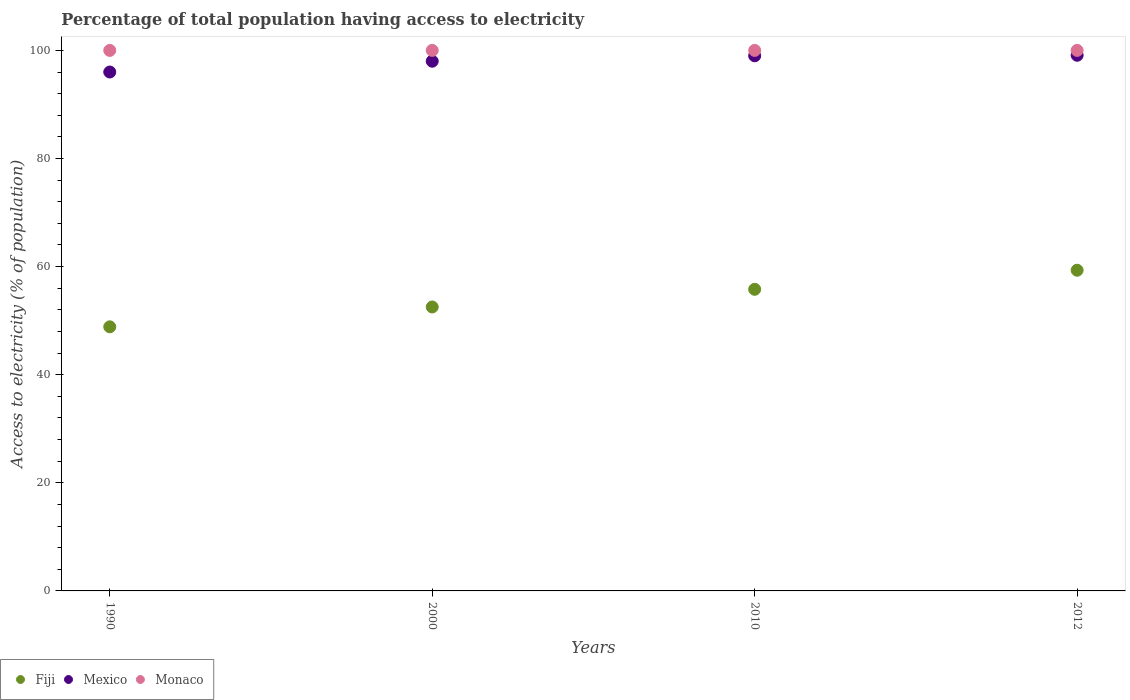What is the percentage of population that have access to electricity in Monaco in 2012?
Provide a short and direct response. 100. Across all years, what is the maximum percentage of population that have access to electricity in Mexico?
Provide a succinct answer. 99.1. Across all years, what is the minimum percentage of population that have access to electricity in Fiji?
Give a very brief answer. 48.86. In which year was the percentage of population that have access to electricity in Fiji minimum?
Offer a very short reply. 1990. What is the total percentage of population that have access to electricity in Fiji in the graph?
Your response must be concise. 216.52. What is the difference between the percentage of population that have access to electricity in Fiji in 1990 and that in 2010?
Your answer should be compact. -6.94. What is the difference between the percentage of population that have access to electricity in Monaco in 1990 and the percentage of population that have access to electricity in Fiji in 2000?
Your answer should be very brief. 47.47. What is the average percentage of population that have access to electricity in Mexico per year?
Your answer should be very brief. 98.03. In the year 2000, what is the difference between the percentage of population that have access to electricity in Monaco and percentage of population that have access to electricity in Fiji?
Provide a short and direct response. 47.47. Is the percentage of population that have access to electricity in Mexico in 2000 less than that in 2012?
Your answer should be very brief. Yes. Is the difference between the percentage of population that have access to electricity in Monaco in 1990 and 2012 greater than the difference between the percentage of population that have access to electricity in Fiji in 1990 and 2012?
Make the answer very short. Yes. What is the difference between the highest and the second highest percentage of population that have access to electricity in Monaco?
Give a very brief answer. 0. What is the difference between the highest and the lowest percentage of population that have access to electricity in Mexico?
Your answer should be compact. 3.1. Is the sum of the percentage of population that have access to electricity in Mexico in 2000 and 2012 greater than the maximum percentage of population that have access to electricity in Fiji across all years?
Ensure brevity in your answer.  Yes. How many years are there in the graph?
Your response must be concise. 4. Does the graph contain grids?
Your answer should be compact. No. How many legend labels are there?
Provide a short and direct response. 3. What is the title of the graph?
Ensure brevity in your answer.  Percentage of total population having access to electricity. What is the label or title of the X-axis?
Provide a short and direct response. Years. What is the label or title of the Y-axis?
Your answer should be very brief. Access to electricity (% of population). What is the Access to electricity (% of population) in Fiji in 1990?
Offer a very short reply. 48.86. What is the Access to electricity (% of population) in Mexico in 1990?
Make the answer very short. 96. What is the Access to electricity (% of population) in Monaco in 1990?
Offer a terse response. 100. What is the Access to electricity (% of population) of Fiji in 2000?
Keep it short and to the point. 52.53. What is the Access to electricity (% of population) of Monaco in 2000?
Provide a short and direct response. 100. What is the Access to electricity (% of population) in Fiji in 2010?
Offer a very short reply. 55.8. What is the Access to electricity (% of population) of Fiji in 2012?
Make the answer very short. 59.33. What is the Access to electricity (% of population) of Mexico in 2012?
Offer a terse response. 99.1. What is the Access to electricity (% of population) of Monaco in 2012?
Ensure brevity in your answer.  100. Across all years, what is the maximum Access to electricity (% of population) of Fiji?
Provide a short and direct response. 59.33. Across all years, what is the maximum Access to electricity (% of population) in Mexico?
Your answer should be very brief. 99.1. Across all years, what is the maximum Access to electricity (% of population) of Monaco?
Give a very brief answer. 100. Across all years, what is the minimum Access to electricity (% of population) of Fiji?
Your response must be concise. 48.86. Across all years, what is the minimum Access to electricity (% of population) of Mexico?
Ensure brevity in your answer.  96. What is the total Access to electricity (% of population) of Fiji in the graph?
Your response must be concise. 216.52. What is the total Access to electricity (% of population) of Mexico in the graph?
Your response must be concise. 392.1. What is the total Access to electricity (% of population) of Monaco in the graph?
Ensure brevity in your answer.  400. What is the difference between the Access to electricity (% of population) in Fiji in 1990 and that in 2000?
Provide a short and direct response. -3.67. What is the difference between the Access to electricity (% of population) of Monaco in 1990 and that in 2000?
Offer a terse response. 0. What is the difference between the Access to electricity (% of population) of Fiji in 1990 and that in 2010?
Make the answer very short. -6.94. What is the difference between the Access to electricity (% of population) of Monaco in 1990 and that in 2010?
Your answer should be compact. 0. What is the difference between the Access to electricity (% of population) of Fiji in 1990 and that in 2012?
Ensure brevity in your answer.  -10.47. What is the difference between the Access to electricity (% of population) of Mexico in 1990 and that in 2012?
Offer a very short reply. -3.1. What is the difference between the Access to electricity (% of population) in Fiji in 2000 and that in 2010?
Keep it short and to the point. -3.27. What is the difference between the Access to electricity (% of population) in Mexico in 2000 and that in 2010?
Your response must be concise. -1. What is the difference between the Access to electricity (% of population) in Fiji in 2000 and that in 2012?
Give a very brief answer. -6.8. What is the difference between the Access to electricity (% of population) of Monaco in 2000 and that in 2012?
Your answer should be compact. 0. What is the difference between the Access to electricity (% of population) of Fiji in 2010 and that in 2012?
Make the answer very short. -3.53. What is the difference between the Access to electricity (% of population) in Monaco in 2010 and that in 2012?
Your answer should be compact. 0. What is the difference between the Access to electricity (% of population) in Fiji in 1990 and the Access to electricity (% of population) in Mexico in 2000?
Keep it short and to the point. -49.14. What is the difference between the Access to electricity (% of population) of Fiji in 1990 and the Access to electricity (% of population) of Monaco in 2000?
Your response must be concise. -51.14. What is the difference between the Access to electricity (% of population) of Mexico in 1990 and the Access to electricity (% of population) of Monaco in 2000?
Make the answer very short. -4. What is the difference between the Access to electricity (% of population) in Fiji in 1990 and the Access to electricity (% of population) in Mexico in 2010?
Your answer should be compact. -50.14. What is the difference between the Access to electricity (% of population) in Fiji in 1990 and the Access to electricity (% of population) in Monaco in 2010?
Make the answer very short. -51.14. What is the difference between the Access to electricity (% of population) of Fiji in 1990 and the Access to electricity (% of population) of Mexico in 2012?
Give a very brief answer. -50.24. What is the difference between the Access to electricity (% of population) of Fiji in 1990 and the Access to electricity (% of population) of Monaco in 2012?
Provide a succinct answer. -51.14. What is the difference between the Access to electricity (% of population) of Fiji in 2000 and the Access to electricity (% of population) of Mexico in 2010?
Keep it short and to the point. -46.47. What is the difference between the Access to electricity (% of population) of Fiji in 2000 and the Access to electricity (% of population) of Monaco in 2010?
Give a very brief answer. -47.47. What is the difference between the Access to electricity (% of population) in Mexico in 2000 and the Access to electricity (% of population) in Monaco in 2010?
Your response must be concise. -2. What is the difference between the Access to electricity (% of population) in Fiji in 2000 and the Access to electricity (% of population) in Mexico in 2012?
Your answer should be compact. -46.57. What is the difference between the Access to electricity (% of population) in Fiji in 2000 and the Access to electricity (% of population) in Monaco in 2012?
Offer a very short reply. -47.47. What is the difference between the Access to electricity (% of population) in Mexico in 2000 and the Access to electricity (% of population) in Monaco in 2012?
Your answer should be very brief. -2. What is the difference between the Access to electricity (% of population) of Fiji in 2010 and the Access to electricity (% of population) of Mexico in 2012?
Provide a succinct answer. -43.3. What is the difference between the Access to electricity (% of population) in Fiji in 2010 and the Access to electricity (% of population) in Monaco in 2012?
Make the answer very short. -44.2. What is the average Access to electricity (% of population) of Fiji per year?
Your answer should be compact. 54.13. What is the average Access to electricity (% of population) of Mexico per year?
Offer a terse response. 98.03. In the year 1990, what is the difference between the Access to electricity (% of population) of Fiji and Access to electricity (% of population) of Mexico?
Ensure brevity in your answer.  -47.14. In the year 1990, what is the difference between the Access to electricity (% of population) in Fiji and Access to electricity (% of population) in Monaco?
Provide a succinct answer. -51.14. In the year 1990, what is the difference between the Access to electricity (% of population) of Mexico and Access to electricity (% of population) of Monaco?
Your answer should be compact. -4. In the year 2000, what is the difference between the Access to electricity (% of population) of Fiji and Access to electricity (% of population) of Mexico?
Offer a terse response. -45.47. In the year 2000, what is the difference between the Access to electricity (% of population) of Fiji and Access to electricity (% of population) of Monaco?
Provide a short and direct response. -47.47. In the year 2010, what is the difference between the Access to electricity (% of population) in Fiji and Access to electricity (% of population) in Mexico?
Keep it short and to the point. -43.2. In the year 2010, what is the difference between the Access to electricity (% of population) of Fiji and Access to electricity (% of population) of Monaco?
Offer a very short reply. -44.2. In the year 2010, what is the difference between the Access to electricity (% of population) in Mexico and Access to electricity (% of population) in Monaco?
Keep it short and to the point. -1. In the year 2012, what is the difference between the Access to electricity (% of population) in Fiji and Access to electricity (% of population) in Mexico?
Give a very brief answer. -39.77. In the year 2012, what is the difference between the Access to electricity (% of population) in Fiji and Access to electricity (% of population) in Monaco?
Your answer should be compact. -40.67. What is the ratio of the Access to electricity (% of population) in Fiji in 1990 to that in 2000?
Provide a succinct answer. 0.93. What is the ratio of the Access to electricity (% of population) in Mexico in 1990 to that in 2000?
Give a very brief answer. 0.98. What is the ratio of the Access to electricity (% of population) in Fiji in 1990 to that in 2010?
Ensure brevity in your answer.  0.88. What is the ratio of the Access to electricity (% of population) in Mexico in 1990 to that in 2010?
Give a very brief answer. 0.97. What is the ratio of the Access to electricity (% of population) of Monaco in 1990 to that in 2010?
Your response must be concise. 1. What is the ratio of the Access to electricity (% of population) of Fiji in 1990 to that in 2012?
Give a very brief answer. 0.82. What is the ratio of the Access to electricity (% of population) of Mexico in 1990 to that in 2012?
Offer a very short reply. 0.97. What is the ratio of the Access to electricity (% of population) in Monaco in 1990 to that in 2012?
Give a very brief answer. 1. What is the ratio of the Access to electricity (% of population) in Fiji in 2000 to that in 2010?
Make the answer very short. 0.94. What is the ratio of the Access to electricity (% of population) in Mexico in 2000 to that in 2010?
Your response must be concise. 0.99. What is the ratio of the Access to electricity (% of population) of Monaco in 2000 to that in 2010?
Your answer should be very brief. 1. What is the ratio of the Access to electricity (% of population) of Fiji in 2000 to that in 2012?
Provide a short and direct response. 0.89. What is the ratio of the Access to electricity (% of population) in Mexico in 2000 to that in 2012?
Make the answer very short. 0.99. What is the ratio of the Access to electricity (% of population) in Monaco in 2000 to that in 2012?
Keep it short and to the point. 1. What is the ratio of the Access to electricity (% of population) in Fiji in 2010 to that in 2012?
Provide a succinct answer. 0.94. What is the ratio of the Access to electricity (% of population) of Monaco in 2010 to that in 2012?
Keep it short and to the point. 1. What is the difference between the highest and the second highest Access to electricity (% of population) in Fiji?
Offer a terse response. 3.53. What is the difference between the highest and the second highest Access to electricity (% of population) in Mexico?
Keep it short and to the point. 0.1. What is the difference between the highest and the second highest Access to electricity (% of population) of Monaco?
Provide a short and direct response. 0. What is the difference between the highest and the lowest Access to electricity (% of population) of Fiji?
Ensure brevity in your answer.  10.47. What is the difference between the highest and the lowest Access to electricity (% of population) of Mexico?
Your answer should be very brief. 3.1. 